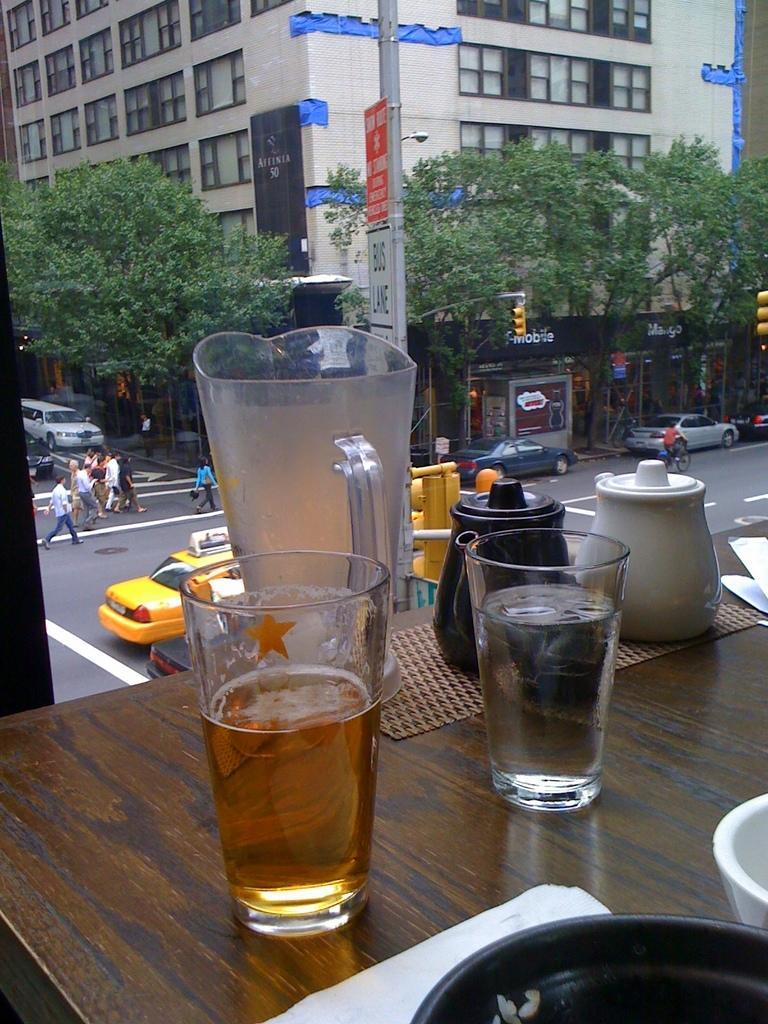Please provide a concise description of this image. In this image I can see the table. On the table there are glasses, jug, teapots, bowls can be seen. To the side I can see the road. On the road there are many vehicles and the group of people with different color dresses. In the background I can see the boards, signal lights, trees and the building with windows. 